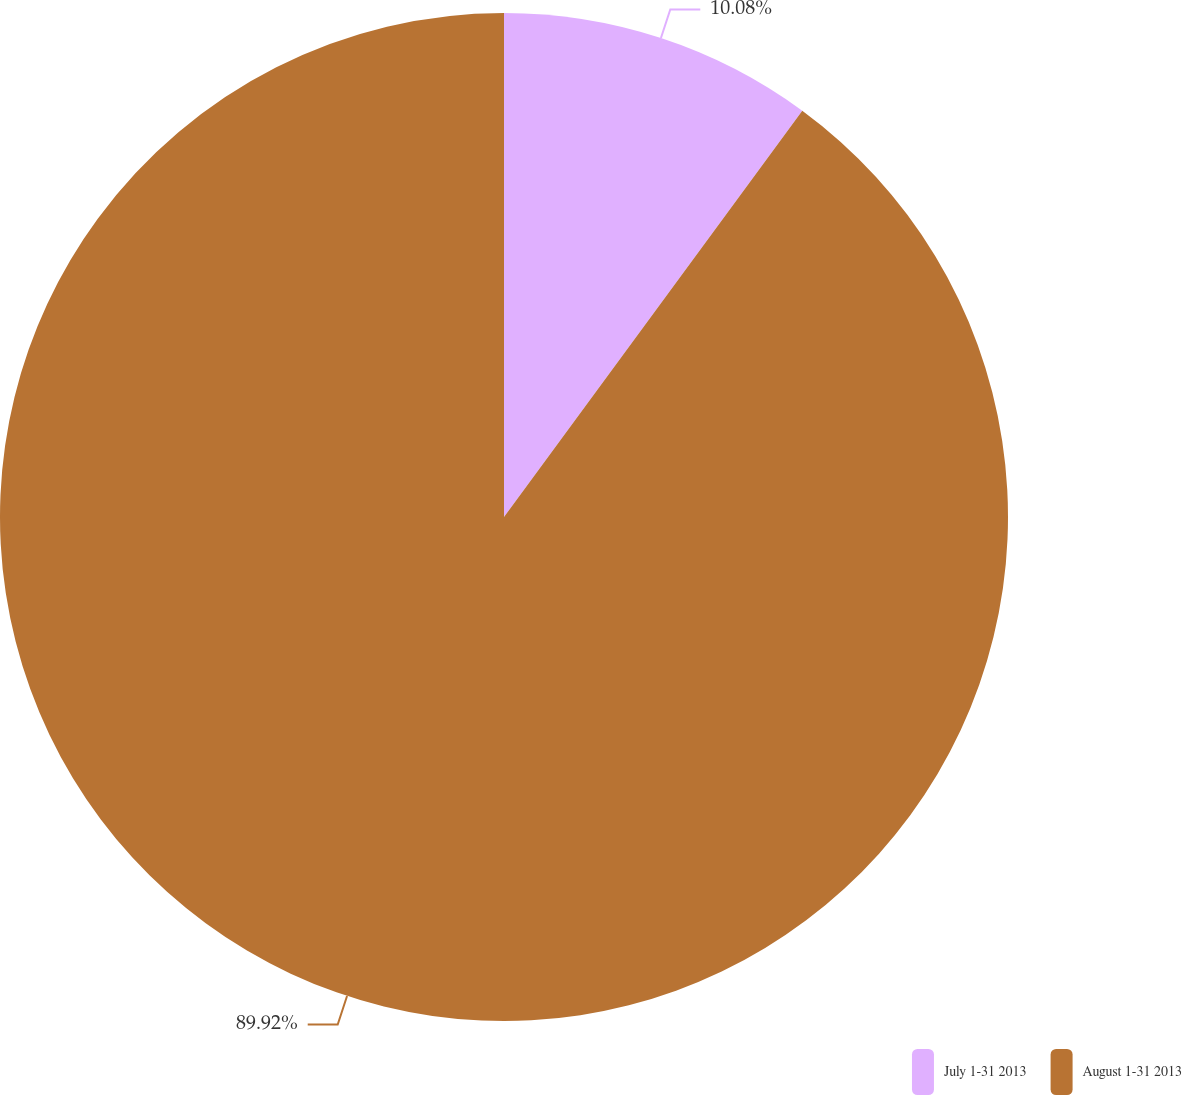Convert chart to OTSL. <chart><loc_0><loc_0><loc_500><loc_500><pie_chart><fcel>July 1-31 2013<fcel>August 1-31 2013<nl><fcel>10.08%<fcel>89.92%<nl></chart> 